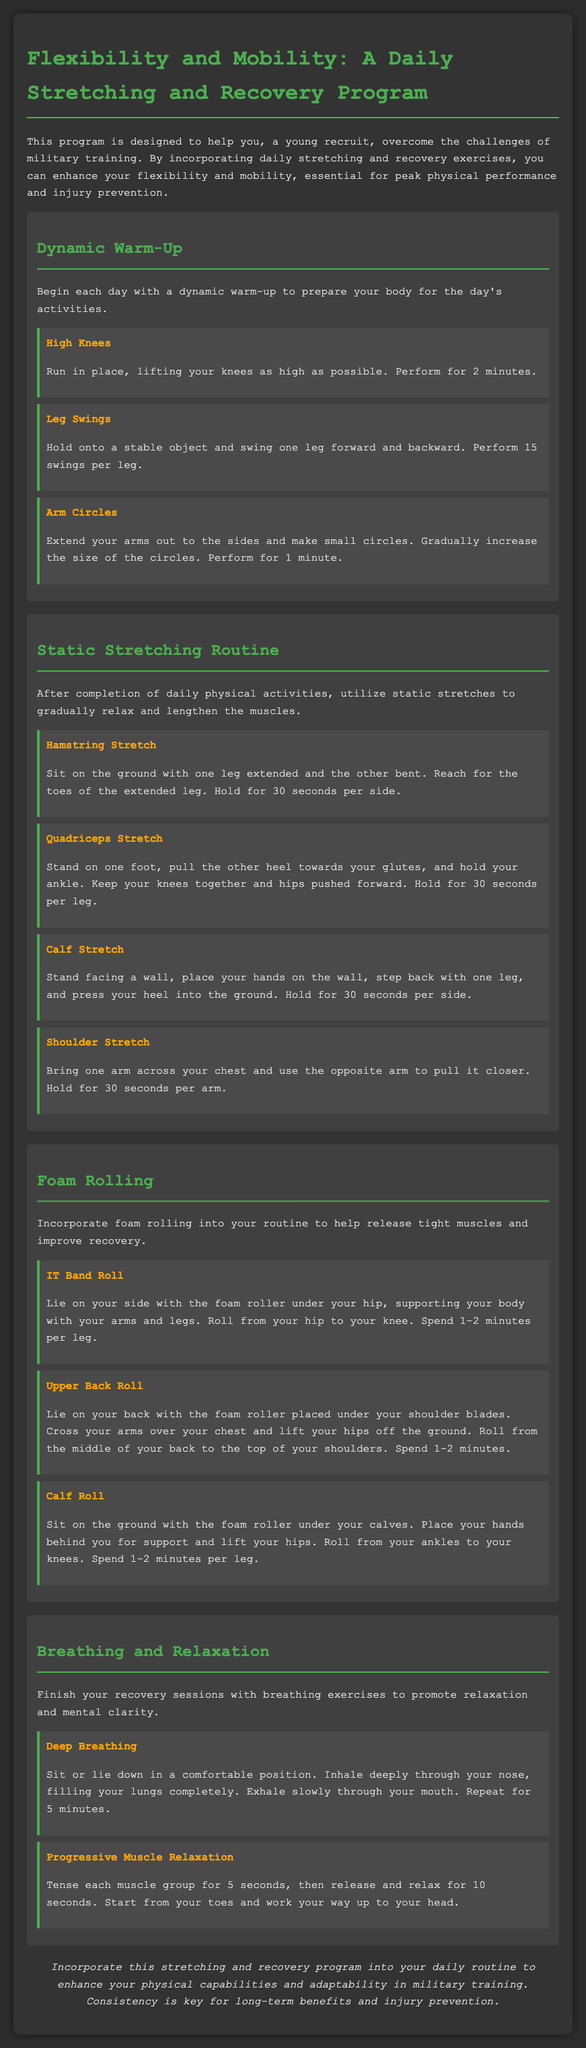What is the main purpose of the program? The program is designed to help recruits overcome challenges in military training by enhancing flexibility and mobility, essential for peak physical performance and injury prevention.
Answer: To help recruits How long should you perform High Knees? The document states you should perform High Knees for 2 minutes.
Answer: 2 minutes What should follow the daily physical activities? After daily physical activities, you should utilize static stretches.
Answer: Static stretches How long should each muscle group be tensed during Progressive Muscle Relaxation? Each muscle group should be tensed for 5 seconds.
Answer: 5 seconds What exercise helps release tight muscles? The exercise to release tight muscles is foam rolling.
Answer: Foam rolling What is the duration for Deep Breathing exercises? Deep Breathing exercises should be repeated for 5 minutes.
Answer: 5 minutes 